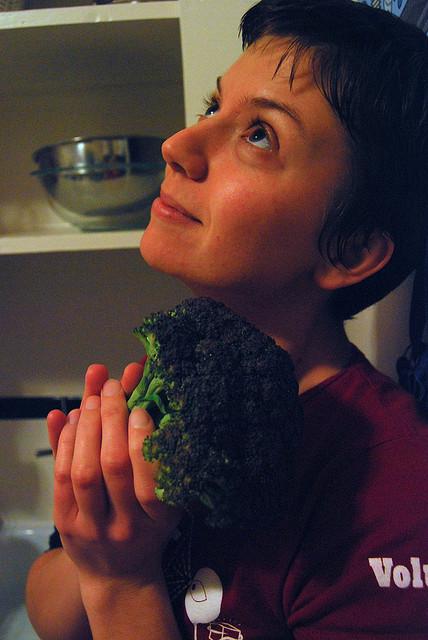Where is the broccoli?
Answer briefly. In her hand. What color is this person's shirt?
Be succinct. Red. Is this person wearing any earrings?
Write a very short answer. No. What is green?
Be succinct. Broccoli. 